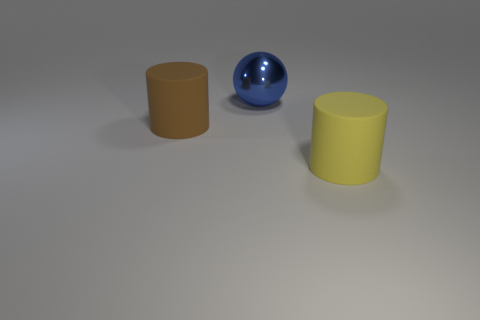There is a big thing that is the same material as the big brown cylinder; what shape is it?
Offer a very short reply. Cylinder. Are there any other things that are the same shape as the brown matte object?
Offer a very short reply. Yes. What is the shape of the yellow rubber object?
Your response must be concise. Cylinder. Do the rubber object that is behind the large yellow matte thing and the large yellow object have the same shape?
Provide a succinct answer. Yes. Are there more cylinders behind the big brown cylinder than blue balls to the left of the sphere?
Your answer should be very brief. No. What number of other objects are the same size as the brown cylinder?
Provide a short and direct response. 2. There is a big brown rubber object; does it have the same shape as the big thing that is on the right side of the large blue metallic thing?
Ensure brevity in your answer.  Yes. How many rubber things are either yellow things or brown cylinders?
Ensure brevity in your answer.  2. Are there any matte things that have the same color as the big metal ball?
Make the answer very short. No. Is there a large cyan ball?
Ensure brevity in your answer.  No. 